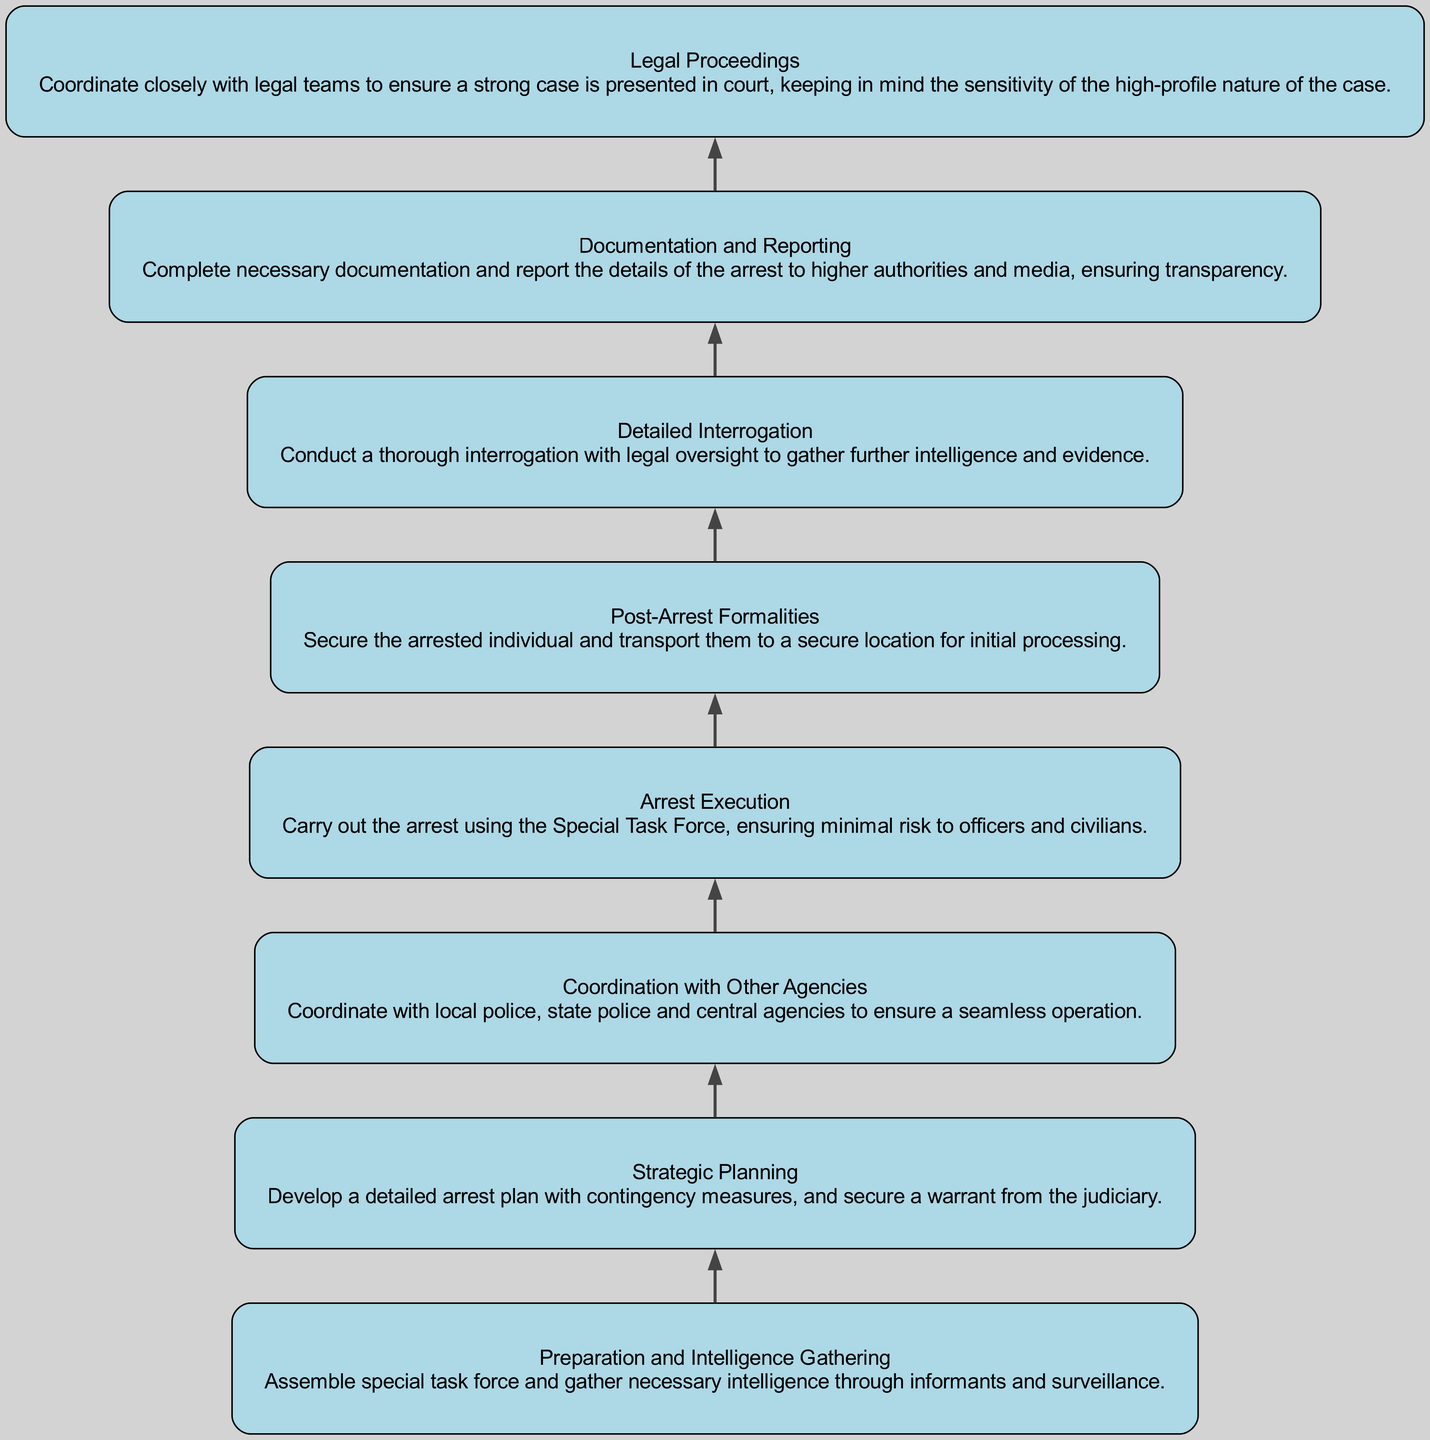what is the first step in the procedure? The first step in the flowchart as indicated by the bottom node is "Preparation and Intelligence Gathering". This step involves assembling a task force and gathering necessary intelligence.
Answer: Preparation and Intelligence Gathering how many nodes are there in the diagram? Counting each step from "Preparation and Intelligence Gathering" to "Legal Proceedings", there are a total of eight distinct nodes representing different stages of the procedure.
Answer: 8 which step directly follows "Arrest Execution"? The step that directly follows "Arrest Execution" is "Post-Arrest Formalities". This indicates the immediate next action after the arrest is made.
Answer: Post-Arrest Formalities what is one of the dependencies for "Detailed Interrogation"? One of the dependencies for "Detailed Interrogation" is "Post-Arrest Formalities". This means that the formalities must be completed before proceeding to interrogation.
Answer: Post-Arrest Formalities which step is the last in the procedure? The last step in the flowchart is "Legal Proceedings". This reflects that after the arrest and interrogation stages, the process culminates in legal action.
Answer: Legal Proceedings what does "Coordination with Other Agencies" depend on? "Coordination with Other Agencies" depends on "Strategic Planning". This highlights that strategic planning must be completed before coordination can occur.
Answer: Strategic Planning what step involves securing the arrested individual? The step that involves securing the arrested individual is "Post-Arrest Formalities". This step is crucial for initial processing of the arrested individual.
Answer: Post-Arrest Formalities which step requires a warrant from the judiciary? The step that requires a warrant from the judiciary is "Strategic Planning". This indicates legal approval is necessary at this stage of planning the arrest.
Answer: Strategic Planning 